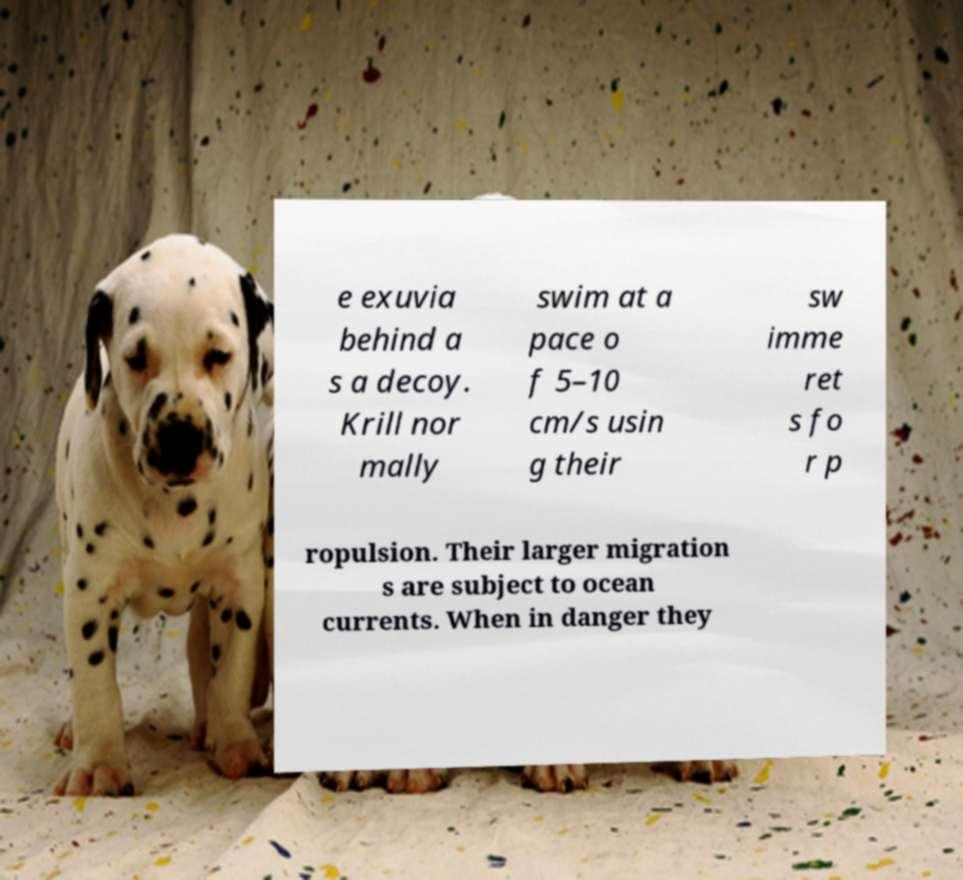For documentation purposes, I need the text within this image transcribed. Could you provide that? e exuvia behind a s a decoy. Krill nor mally swim at a pace o f 5–10 cm/s usin g their sw imme ret s fo r p ropulsion. Their larger migration s are subject to ocean currents. When in danger they 